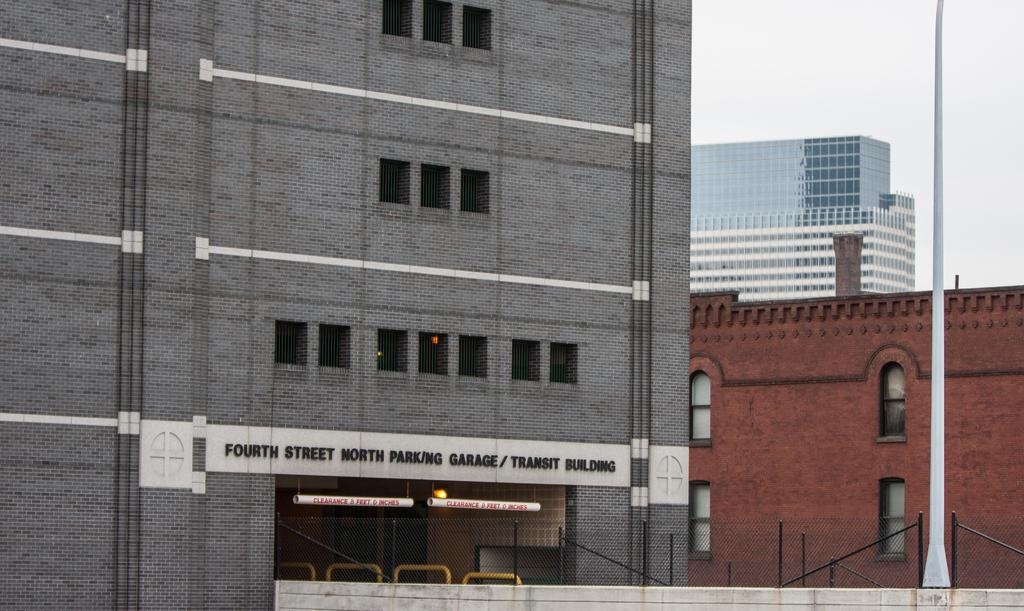What type of structures are present in the image? There are buildings in the image. What feature is common among the buildings? The buildings have many windows. What can be seen above the buildings? The sky is visible above the buildings. How many bikes are parked in front of the buildings in the image? There is no information about bikes in the image, so we cannot determine how many are parked in front of the buildings. 